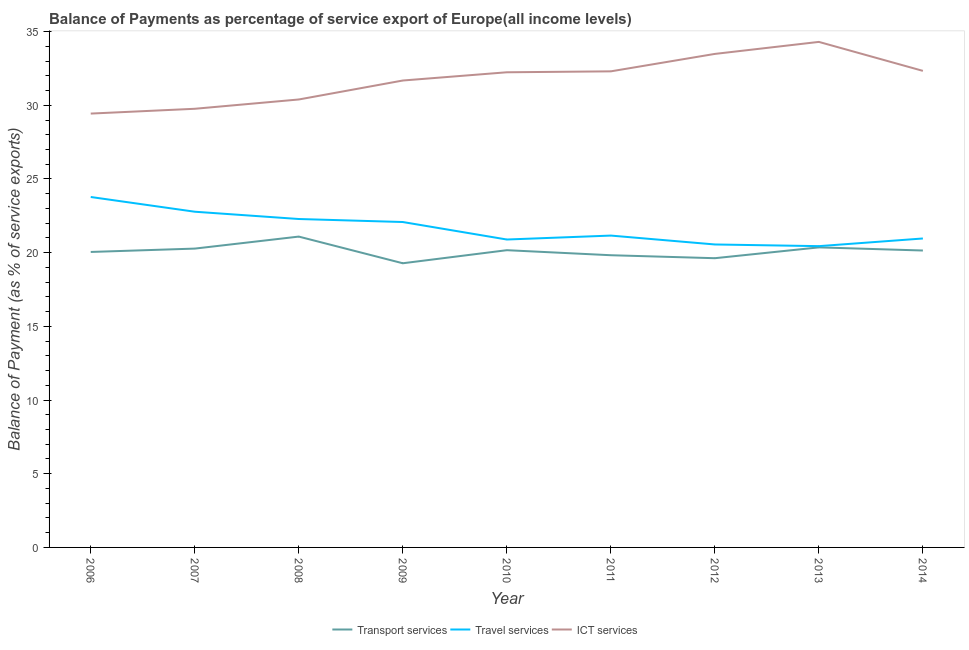How many different coloured lines are there?
Your answer should be compact. 3. What is the balance of payment of ict services in 2014?
Your answer should be very brief. 32.34. Across all years, what is the maximum balance of payment of travel services?
Keep it short and to the point. 23.78. Across all years, what is the minimum balance of payment of travel services?
Your response must be concise. 20.44. In which year was the balance of payment of transport services minimum?
Provide a succinct answer. 2009. What is the total balance of payment of transport services in the graph?
Ensure brevity in your answer.  180.82. What is the difference between the balance of payment of transport services in 2006 and that in 2009?
Provide a short and direct response. 0.77. What is the difference between the balance of payment of travel services in 2007 and the balance of payment of transport services in 2011?
Keep it short and to the point. 2.95. What is the average balance of payment of travel services per year?
Offer a terse response. 21.66. In the year 2007, what is the difference between the balance of payment of travel services and balance of payment of transport services?
Your answer should be very brief. 2.5. What is the ratio of the balance of payment of travel services in 2011 to that in 2012?
Provide a short and direct response. 1.03. Is the balance of payment of ict services in 2010 less than that in 2011?
Make the answer very short. Yes. Is the difference between the balance of payment of transport services in 2009 and 2014 greater than the difference between the balance of payment of ict services in 2009 and 2014?
Keep it short and to the point. No. What is the difference between the highest and the second highest balance of payment of travel services?
Keep it short and to the point. 1. What is the difference between the highest and the lowest balance of payment of transport services?
Offer a terse response. 1.81. Is the sum of the balance of payment of ict services in 2011 and 2012 greater than the maximum balance of payment of transport services across all years?
Ensure brevity in your answer.  Yes. Is it the case that in every year, the sum of the balance of payment of transport services and balance of payment of travel services is greater than the balance of payment of ict services?
Provide a succinct answer. Yes. Is the balance of payment of ict services strictly less than the balance of payment of travel services over the years?
Offer a very short reply. No. What is the difference between two consecutive major ticks on the Y-axis?
Keep it short and to the point. 5. Are the values on the major ticks of Y-axis written in scientific E-notation?
Make the answer very short. No. How many legend labels are there?
Offer a terse response. 3. What is the title of the graph?
Ensure brevity in your answer.  Balance of Payments as percentage of service export of Europe(all income levels). Does "Private sector" appear as one of the legend labels in the graph?
Give a very brief answer. No. What is the label or title of the X-axis?
Offer a terse response. Year. What is the label or title of the Y-axis?
Your answer should be compact. Balance of Payment (as % of service exports). What is the Balance of Payment (as % of service exports) in Transport services in 2006?
Offer a very short reply. 20.05. What is the Balance of Payment (as % of service exports) of Travel services in 2006?
Provide a succinct answer. 23.78. What is the Balance of Payment (as % of service exports) in ICT services in 2006?
Your response must be concise. 29.44. What is the Balance of Payment (as % of service exports) in Transport services in 2007?
Your answer should be compact. 20.28. What is the Balance of Payment (as % of service exports) of Travel services in 2007?
Provide a short and direct response. 22.78. What is the Balance of Payment (as % of service exports) of ICT services in 2007?
Provide a short and direct response. 29.76. What is the Balance of Payment (as % of service exports) of Transport services in 2008?
Ensure brevity in your answer.  21.09. What is the Balance of Payment (as % of service exports) in Travel services in 2008?
Make the answer very short. 22.28. What is the Balance of Payment (as % of service exports) of ICT services in 2008?
Ensure brevity in your answer.  30.39. What is the Balance of Payment (as % of service exports) in Transport services in 2009?
Offer a very short reply. 19.28. What is the Balance of Payment (as % of service exports) in Travel services in 2009?
Give a very brief answer. 22.08. What is the Balance of Payment (as % of service exports) in ICT services in 2009?
Offer a terse response. 31.68. What is the Balance of Payment (as % of service exports) in Transport services in 2010?
Ensure brevity in your answer.  20.17. What is the Balance of Payment (as % of service exports) in Travel services in 2010?
Provide a short and direct response. 20.89. What is the Balance of Payment (as % of service exports) in ICT services in 2010?
Keep it short and to the point. 32.24. What is the Balance of Payment (as % of service exports) of Transport services in 2011?
Offer a very short reply. 19.83. What is the Balance of Payment (as % of service exports) of Travel services in 2011?
Make the answer very short. 21.16. What is the Balance of Payment (as % of service exports) in ICT services in 2011?
Ensure brevity in your answer.  32.3. What is the Balance of Payment (as % of service exports) of Transport services in 2012?
Provide a short and direct response. 19.62. What is the Balance of Payment (as % of service exports) of Travel services in 2012?
Make the answer very short. 20.56. What is the Balance of Payment (as % of service exports) in ICT services in 2012?
Offer a very short reply. 33.49. What is the Balance of Payment (as % of service exports) of Transport services in 2013?
Make the answer very short. 20.36. What is the Balance of Payment (as % of service exports) in Travel services in 2013?
Your answer should be compact. 20.44. What is the Balance of Payment (as % of service exports) in ICT services in 2013?
Give a very brief answer. 34.3. What is the Balance of Payment (as % of service exports) of Transport services in 2014?
Your answer should be compact. 20.15. What is the Balance of Payment (as % of service exports) of Travel services in 2014?
Ensure brevity in your answer.  20.96. What is the Balance of Payment (as % of service exports) in ICT services in 2014?
Give a very brief answer. 32.34. Across all years, what is the maximum Balance of Payment (as % of service exports) of Transport services?
Offer a very short reply. 21.09. Across all years, what is the maximum Balance of Payment (as % of service exports) in Travel services?
Give a very brief answer. 23.78. Across all years, what is the maximum Balance of Payment (as % of service exports) of ICT services?
Make the answer very short. 34.3. Across all years, what is the minimum Balance of Payment (as % of service exports) of Transport services?
Your answer should be compact. 19.28. Across all years, what is the minimum Balance of Payment (as % of service exports) in Travel services?
Your answer should be very brief. 20.44. Across all years, what is the minimum Balance of Payment (as % of service exports) of ICT services?
Ensure brevity in your answer.  29.44. What is the total Balance of Payment (as % of service exports) of Transport services in the graph?
Offer a very short reply. 180.82. What is the total Balance of Payment (as % of service exports) in Travel services in the graph?
Your response must be concise. 194.93. What is the total Balance of Payment (as % of service exports) of ICT services in the graph?
Make the answer very short. 285.94. What is the difference between the Balance of Payment (as % of service exports) of Transport services in 2006 and that in 2007?
Your answer should be compact. -0.23. What is the difference between the Balance of Payment (as % of service exports) in ICT services in 2006 and that in 2007?
Your response must be concise. -0.33. What is the difference between the Balance of Payment (as % of service exports) in Transport services in 2006 and that in 2008?
Your answer should be very brief. -1.04. What is the difference between the Balance of Payment (as % of service exports) of Travel services in 2006 and that in 2008?
Offer a terse response. 1.49. What is the difference between the Balance of Payment (as % of service exports) in ICT services in 2006 and that in 2008?
Ensure brevity in your answer.  -0.96. What is the difference between the Balance of Payment (as % of service exports) of Transport services in 2006 and that in 2009?
Keep it short and to the point. 0.77. What is the difference between the Balance of Payment (as % of service exports) in Travel services in 2006 and that in 2009?
Provide a succinct answer. 1.7. What is the difference between the Balance of Payment (as % of service exports) of ICT services in 2006 and that in 2009?
Give a very brief answer. -2.24. What is the difference between the Balance of Payment (as % of service exports) in Transport services in 2006 and that in 2010?
Offer a very short reply. -0.12. What is the difference between the Balance of Payment (as % of service exports) in Travel services in 2006 and that in 2010?
Keep it short and to the point. 2.88. What is the difference between the Balance of Payment (as % of service exports) in ICT services in 2006 and that in 2010?
Provide a succinct answer. -2.8. What is the difference between the Balance of Payment (as % of service exports) of Transport services in 2006 and that in 2011?
Offer a terse response. 0.22. What is the difference between the Balance of Payment (as % of service exports) in Travel services in 2006 and that in 2011?
Your response must be concise. 2.62. What is the difference between the Balance of Payment (as % of service exports) in ICT services in 2006 and that in 2011?
Your answer should be compact. -2.87. What is the difference between the Balance of Payment (as % of service exports) of Transport services in 2006 and that in 2012?
Your response must be concise. 0.42. What is the difference between the Balance of Payment (as % of service exports) in Travel services in 2006 and that in 2012?
Provide a succinct answer. 3.22. What is the difference between the Balance of Payment (as % of service exports) of ICT services in 2006 and that in 2012?
Provide a succinct answer. -4.05. What is the difference between the Balance of Payment (as % of service exports) in Transport services in 2006 and that in 2013?
Provide a short and direct response. -0.31. What is the difference between the Balance of Payment (as % of service exports) in Travel services in 2006 and that in 2013?
Keep it short and to the point. 3.33. What is the difference between the Balance of Payment (as % of service exports) of ICT services in 2006 and that in 2013?
Ensure brevity in your answer.  -4.86. What is the difference between the Balance of Payment (as % of service exports) of Transport services in 2006 and that in 2014?
Provide a succinct answer. -0.1. What is the difference between the Balance of Payment (as % of service exports) in Travel services in 2006 and that in 2014?
Make the answer very short. 2.81. What is the difference between the Balance of Payment (as % of service exports) in ICT services in 2006 and that in 2014?
Your answer should be very brief. -2.9. What is the difference between the Balance of Payment (as % of service exports) in Transport services in 2007 and that in 2008?
Your answer should be very brief. -0.82. What is the difference between the Balance of Payment (as % of service exports) in Travel services in 2007 and that in 2008?
Your answer should be compact. 0.49. What is the difference between the Balance of Payment (as % of service exports) of ICT services in 2007 and that in 2008?
Offer a very short reply. -0.63. What is the difference between the Balance of Payment (as % of service exports) of Transport services in 2007 and that in 2009?
Offer a very short reply. 0.99. What is the difference between the Balance of Payment (as % of service exports) in Travel services in 2007 and that in 2009?
Your answer should be very brief. 0.7. What is the difference between the Balance of Payment (as % of service exports) in ICT services in 2007 and that in 2009?
Give a very brief answer. -1.92. What is the difference between the Balance of Payment (as % of service exports) in Transport services in 2007 and that in 2010?
Ensure brevity in your answer.  0.11. What is the difference between the Balance of Payment (as % of service exports) in Travel services in 2007 and that in 2010?
Offer a very short reply. 1.89. What is the difference between the Balance of Payment (as % of service exports) in ICT services in 2007 and that in 2010?
Your answer should be compact. -2.48. What is the difference between the Balance of Payment (as % of service exports) in Transport services in 2007 and that in 2011?
Your answer should be very brief. 0.45. What is the difference between the Balance of Payment (as % of service exports) of Travel services in 2007 and that in 2011?
Give a very brief answer. 1.62. What is the difference between the Balance of Payment (as % of service exports) in ICT services in 2007 and that in 2011?
Provide a succinct answer. -2.54. What is the difference between the Balance of Payment (as % of service exports) of Transport services in 2007 and that in 2012?
Give a very brief answer. 0.65. What is the difference between the Balance of Payment (as % of service exports) of Travel services in 2007 and that in 2012?
Give a very brief answer. 2.22. What is the difference between the Balance of Payment (as % of service exports) of ICT services in 2007 and that in 2012?
Your response must be concise. -3.72. What is the difference between the Balance of Payment (as % of service exports) in Transport services in 2007 and that in 2013?
Your answer should be very brief. -0.08. What is the difference between the Balance of Payment (as % of service exports) in Travel services in 2007 and that in 2013?
Your answer should be very brief. 2.34. What is the difference between the Balance of Payment (as % of service exports) of ICT services in 2007 and that in 2013?
Provide a short and direct response. -4.54. What is the difference between the Balance of Payment (as % of service exports) in Transport services in 2007 and that in 2014?
Provide a succinct answer. 0.13. What is the difference between the Balance of Payment (as % of service exports) in Travel services in 2007 and that in 2014?
Your answer should be compact. 1.82. What is the difference between the Balance of Payment (as % of service exports) in ICT services in 2007 and that in 2014?
Ensure brevity in your answer.  -2.57. What is the difference between the Balance of Payment (as % of service exports) of Transport services in 2008 and that in 2009?
Your response must be concise. 1.81. What is the difference between the Balance of Payment (as % of service exports) of Travel services in 2008 and that in 2009?
Provide a succinct answer. 0.2. What is the difference between the Balance of Payment (as % of service exports) of ICT services in 2008 and that in 2009?
Keep it short and to the point. -1.29. What is the difference between the Balance of Payment (as % of service exports) in Travel services in 2008 and that in 2010?
Keep it short and to the point. 1.39. What is the difference between the Balance of Payment (as % of service exports) in ICT services in 2008 and that in 2010?
Ensure brevity in your answer.  -1.85. What is the difference between the Balance of Payment (as % of service exports) in Transport services in 2008 and that in 2011?
Make the answer very short. 1.26. What is the difference between the Balance of Payment (as % of service exports) of Travel services in 2008 and that in 2011?
Keep it short and to the point. 1.12. What is the difference between the Balance of Payment (as % of service exports) in ICT services in 2008 and that in 2011?
Offer a very short reply. -1.91. What is the difference between the Balance of Payment (as % of service exports) in Transport services in 2008 and that in 2012?
Your answer should be very brief. 1.47. What is the difference between the Balance of Payment (as % of service exports) of Travel services in 2008 and that in 2012?
Ensure brevity in your answer.  1.73. What is the difference between the Balance of Payment (as % of service exports) in ICT services in 2008 and that in 2012?
Provide a succinct answer. -3.09. What is the difference between the Balance of Payment (as % of service exports) of Transport services in 2008 and that in 2013?
Make the answer very short. 0.73. What is the difference between the Balance of Payment (as % of service exports) in Travel services in 2008 and that in 2013?
Your answer should be very brief. 1.84. What is the difference between the Balance of Payment (as % of service exports) of ICT services in 2008 and that in 2013?
Your answer should be compact. -3.91. What is the difference between the Balance of Payment (as % of service exports) in Transport services in 2008 and that in 2014?
Your answer should be very brief. 0.94. What is the difference between the Balance of Payment (as % of service exports) in Travel services in 2008 and that in 2014?
Your answer should be compact. 1.32. What is the difference between the Balance of Payment (as % of service exports) in ICT services in 2008 and that in 2014?
Provide a succinct answer. -1.94. What is the difference between the Balance of Payment (as % of service exports) in Transport services in 2009 and that in 2010?
Your answer should be very brief. -0.89. What is the difference between the Balance of Payment (as % of service exports) in Travel services in 2009 and that in 2010?
Give a very brief answer. 1.19. What is the difference between the Balance of Payment (as % of service exports) in ICT services in 2009 and that in 2010?
Provide a succinct answer. -0.56. What is the difference between the Balance of Payment (as % of service exports) of Transport services in 2009 and that in 2011?
Offer a terse response. -0.55. What is the difference between the Balance of Payment (as % of service exports) in Travel services in 2009 and that in 2011?
Ensure brevity in your answer.  0.92. What is the difference between the Balance of Payment (as % of service exports) in ICT services in 2009 and that in 2011?
Your answer should be compact. -0.62. What is the difference between the Balance of Payment (as % of service exports) of Transport services in 2009 and that in 2012?
Provide a short and direct response. -0.34. What is the difference between the Balance of Payment (as % of service exports) of Travel services in 2009 and that in 2012?
Your answer should be very brief. 1.52. What is the difference between the Balance of Payment (as % of service exports) in ICT services in 2009 and that in 2012?
Your answer should be very brief. -1.81. What is the difference between the Balance of Payment (as % of service exports) in Transport services in 2009 and that in 2013?
Your response must be concise. -1.08. What is the difference between the Balance of Payment (as % of service exports) of Travel services in 2009 and that in 2013?
Your response must be concise. 1.64. What is the difference between the Balance of Payment (as % of service exports) of ICT services in 2009 and that in 2013?
Give a very brief answer. -2.62. What is the difference between the Balance of Payment (as % of service exports) in Transport services in 2009 and that in 2014?
Your answer should be very brief. -0.87. What is the difference between the Balance of Payment (as % of service exports) in Travel services in 2009 and that in 2014?
Offer a very short reply. 1.12. What is the difference between the Balance of Payment (as % of service exports) in ICT services in 2009 and that in 2014?
Ensure brevity in your answer.  -0.65. What is the difference between the Balance of Payment (as % of service exports) of Transport services in 2010 and that in 2011?
Your response must be concise. 0.34. What is the difference between the Balance of Payment (as % of service exports) in Travel services in 2010 and that in 2011?
Your response must be concise. -0.27. What is the difference between the Balance of Payment (as % of service exports) of ICT services in 2010 and that in 2011?
Keep it short and to the point. -0.06. What is the difference between the Balance of Payment (as % of service exports) in Transport services in 2010 and that in 2012?
Make the answer very short. 0.54. What is the difference between the Balance of Payment (as % of service exports) in Travel services in 2010 and that in 2012?
Provide a short and direct response. 0.34. What is the difference between the Balance of Payment (as % of service exports) in ICT services in 2010 and that in 2012?
Offer a terse response. -1.25. What is the difference between the Balance of Payment (as % of service exports) of Transport services in 2010 and that in 2013?
Make the answer very short. -0.19. What is the difference between the Balance of Payment (as % of service exports) in Travel services in 2010 and that in 2013?
Offer a terse response. 0.45. What is the difference between the Balance of Payment (as % of service exports) in ICT services in 2010 and that in 2013?
Keep it short and to the point. -2.06. What is the difference between the Balance of Payment (as % of service exports) in Transport services in 2010 and that in 2014?
Keep it short and to the point. 0.02. What is the difference between the Balance of Payment (as % of service exports) in Travel services in 2010 and that in 2014?
Your answer should be very brief. -0.07. What is the difference between the Balance of Payment (as % of service exports) in ICT services in 2010 and that in 2014?
Give a very brief answer. -0.1. What is the difference between the Balance of Payment (as % of service exports) of Transport services in 2011 and that in 2012?
Make the answer very short. 0.2. What is the difference between the Balance of Payment (as % of service exports) in Travel services in 2011 and that in 2012?
Make the answer very short. 0.6. What is the difference between the Balance of Payment (as % of service exports) of ICT services in 2011 and that in 2012?
Your answer should be very brief. -1.18. What is the difference between the Balance of Payment (as % of service exports) of Transport services in 2011 and that in 2013?
Provide a succinct answer. -0.53. What is the difference between the Balance of Payment (as % of service exports) in Travel services in 2011 and that in 2013?
Offer a terse response. 0.72. What is the difference between the Balance of Payment (as % of service exports) of ICT services in 2011 and that in 2013?
Give a very brief answer. -2. What is the difference between the Balance of Payment (as % of service exports) in Transport services in 2011 and that in 2014?
Your response must be concise. -0.32. What is the difference between the Balance of Payment (as % of service exports) of Travel services in 2011 and that in 2014?
Your answer should be very brief. 0.2. What is the difference between the Balance of Payment (as % of service exports) in ICT services in 2011 and that in 2014?
Your response must be concise. -0.03. What is the difference between the Balance of Payment (as % of service exports) in Transport services in 2012 and that in 2013?
Give a very brief answer. -0.73. What is the difference between the Balance of Payment (as % of service exports) in Travel services in 2012 and that in 2013?
Offer a terse response. 0.11. What is the difference between the Balance of Payment (as % of service exports) in ICT services in 2012 and that in 2013?
Give a very brief answer. -0.82. What is the difference between the Balance of Payment (as % of service exports) in Transport services in 2012 and that in 2014?
Your answer should be compact. -0.52. What is the difference between the Balance of Payment (as % of service exports) in Travel services in 2012 and that in 2014?
Your answer should be very brief. -0.41. What is the difference between the Balance of Payment (as % of service exports) in ICT services in 2012 and that in 2014?
Offer a terse response. 1.15. What is the difference between the Balance of Payment (as % of service exports) in Transport services in 2013 and that in 2014?
Your answer should be compact. 0.21. What is the difference between the Balance of Payment (as % of service exports) in Travel services in 2013 and that in 2014?
Provide a succinct answer. -0.52. What is the difference between the Balance of Payment (as % of service exports) of ICT services in 2013 and that in 2014?
Make the answer very short. 1.97. What is the difference between the Balance of Payment (as % of service exports) in Transport services in 2006 and the Balance of Payment (as % of service exports) in Travel services in 2007?
Keep it short and to the point. -2.73. What is the difference between the Balance of Payment (as % of service exports) of Transport services in 2006 and the Balance of Payment (as % of service exports) of ICT services in 2007?
Provide a short and direct response. -9.71. What is the difference between the Balance of Payment (as % of service exports) of Travel services in 2006 and the Balance of Payment (as % of service exports) of ICT services in 2007?
Offer a terse response. -5.99. What is the difference between the Balance of Payment (as % of service exports) of Transport services in 2006 and the Balance of Payment (as % of service exports) of Travel services in 2008?
Keep it short and to the point. -2.23. What is the difference between the Balance of Payment (as % of service exports) of Transport services in 2006 and the Balance of Payment (as % of service exports) of ICT services in 2008?
Your answer should be compact. -10.35. What is the difference between the Balance of Payment (as % of service exports) of Travel services in 2006 and the Balance of Payment (as % of service exports) of ICT services in 2008?
Offer a very short reply. -6.62. What is the difference between the Balance of Payment (as % of service exports) of Transport services in 2006 and the Balance of Payment (as % of service exports) of Travel services in 2009?
Your answer should be compact. -2.03. What is the difference between the Balance of Payment (as % of service exports) in Transport services in 2006 and the Balance of Payment (as % of service exports) in ICT services in 2009?
Ensure brevity in your answer.  -11.63. What is the difference between the Balance of Payment (as % of service exports) of Travel services in 2006 and the Balance of Payment (as % of service exports) of ICT services in 2009?
Provide a succinct answer. -7.9. What is the difference between the Balance of Payment (as % of service exports) in Transport services in 2006 and the Balance of Payment (as % of service exports) in Travel services in 2010?
Your response must be concise. -0.84. What is the difference between the Balance of Payment (as % of service exports) in Transport services in 2006 and the Balance of Payment (as % of service exports) in ICT services in 2010?
Give a very brief answer. -12.19. What is the difference between the Balance of Payment (as % of service exports) in Travel services in 2006 and the Balance of Payment (as % of service exports) in ICT services in 2010?
Provide a short and direct response. -8.46. What is the difference between the Balance of Payment (as % of service exports) in Transport services in 2006 and the Balance of Payment (as % of service exports) in Travel services in 2011?
Your answer should be compact. -1.11. What is the difference between the Balance of Payment (as % of service exports) in Transport services in 2006 and the Balance of Payment (as % of service exports) in ICT services in 2011?
Give a very brief answer. -12.25. What is the difference between the Balance of Payment (as % of service exports) in Travel services in 2006 and the Balance of Payment (as % of service exports) in ICT services in 2011?
Offer a terse response. -8.53. What is the difference between the Balance of Payment (as % of service exports) of Transport services in 2006 and the Balance of Payment (as % of service exports) of Travel services in 2012?
Your response must be concise. -0.51. What is the difference between the Balance of Payment (as % of service exports) of Transport services in 2006 and the Balance of Payment (as % of service exports) of ICT services in 2012?
Give a very brief answer. -13.44. What is the difference between the Balance of Payment (as % of service exports) in Travel services in 2006 and the Balance of Payment (as % of service exports) in ICT services in 2012?
Your answer should be compact. -9.71. What is the difference between the Balance of Payment (as % of service exports) in Transport services in 2006 and the Balance of Payment (as % of service exports) in Travel services in 2013?
Provide a succinct answer. -0.39. What is the difference between the Balance of Payment (as % of service exports) of Transport services in 2006 and the Balance of Payment (as % of service exports) of ICT services in 2013?
Offer a very short reply. -14.25. What is the difference between the Balance of Payment (as % of service exports) of Travel services in 2006 and the Balance of Payment (as % of service exports) of ICT services in 2013?
Offer a very short reply. -10.52. What is the difference between the Balance of Payment (as % of service exports) in Transport services in 2006 and the Balance of Payment (as % of service exports) in Travel services in 2014?
Your answer should be very brief. -0.91. What is the difference between the Balance of Payment (as % of service exports) of Transport services in 2006 and the Balance of Payment (as % of service exports) of ICT services in 2014?
Ensure brevity in your answer.  -12.29. What is the difference between the Balance of Payment (as % of service exports) in Travel services in 2006 and the Balance of Payment (as % of service exports) in ICT services in 2014?
Provide a succinct answer. -8.56. What is the difference between the Balance of Payment (as % of service exports) in Transport services in 2007 and the Balance of Payment (as % of service exports) in Travel services in 2008?
Give a very brief answer. -2.01. What is the difference between the Balance of Payment (as % of service exports) of Transport services in 2007 and the Balance of Payment (as % of service exports) of ICT services in 2008?
Your answer should be compact. -10.12. What is the difference between the Balance of Payment (as % of service exports) in Travel services in 2007 and the Balance of Payment (as % of service exports) in ICT services in 2008?
Offer a very short reply. -7.62. What is the difference between the Balance of Payment (as % of service exports) in Transport services in 2007 and the Balance of Payment (as % of service exports) in Travel services in 2009?
Keep it short and to the point. -1.8. What is the difference between the Balance of Payment (as % of service exports) in Transport services in 2007 and the Balance of Payment (as % of service exports) in ICT services in 2009?
Ensure brevity in your answer.  -11.4. What is the difference between the Balance of Payment (as % of service exports) of Travel services in 2007 and the Balance of Payment (as % of service exports) of ICT services in 2009?
Keep it short and to the point. -8.9. What is the difference between the Balance of Payment (as % of service exports) of Transport services in 2007 and the Balance of Payment (as % of service exports) of Travel services in 2010?
Provide a succinct answer. -0.62. What is the difference between the Balance of Payment (as % of service exports) of Transport services in 2007 and the Balance of Payment (as % of service exports) of ICT services in 2010?
Give a very brief answer. -11.96. What is the difference between the Balance of Payment (as % of service exports) of Travel services in 2007 and the Balance of Payment (as % of service exports) of ICT services in 2010?
Your answer should be compact. -9.46. What is the difference between the Balance of Payment (as % of service exports) of Transport services in 2007 and the Balance of Payment (as % of service exports) of Travel services in 2011?
Offer a very short reply. -0.88. What is the difference between the Balance of Payment (as % of service exports) of Transport services in 2007 and the Balance of Payment (as % of service exports) of ICT services in 2011?
Provide a succinct answer. -12.03. What is the difference between the Balance of Payment (as % of service exports) in Travel services in 2007 and the Balance of Payment (as % of service exports) in ICT services in 2011?
Offer a very short reply. -9.52. What is the difference between the Balance of Payment (as % of service exports) in Transport services in 2007 and the Balance of Payment (as % of service exports) in Travel services in 2012?
Make the answer very short. -0.28. What is the difference between the Balance of Payment (as % of service exports) in Transport services in 2007 and the Balance of Payment (as % of service exports) in ICT services in 2012?
Ensure brevity in your answer.  -13.21. What is the difference between the Balance of Payment (as % of service exports) in Travel services in 2007 and the Balance of Payment (as % of service exports) in ICT services in 2012?
Your answer should be very brief. -10.71. What is the difference between the Balance of Payment (as % of service exports) in Transport services in 2007 and the Balance of Payment (as % of service exports) in Travel services in 2013?
Give a very brief answer. -0.17. What is the difference between the Balance of Payment (as % of service exports) of Transport services in 2007 and the Balance of Payment (as % of service exports) of ICT services in 2013?
Your answer should be very brief. -14.03. What is the difference between the Balance of Payment (as % of service exports) in Travel services in 2007 and the Balance of Payment (as % of service exports) in ICT services in 2013?
Your answer should be very brief. -11.52. What is the difference between the Balance of Payment (as % of service exports) in Transport services in 2007 and the Balance of Payment (as % of service exports) in Travel services in 2014?
Your response must be concise. -0.69. What is the difference between the Balance of Payment (as % of service exports) in Transport services in 2007 and the Balance of Payment (as % of service exports) in ICT services in 2014?
Offer a terse response. -12.06. What is the difference between the Balance of Payment (as % of service exports) of Travel services in 2007 and the Balance of Payment (as % of service exports) of ICT services in 2014?
Ensure brevity in your answer.  -9.56. What is the difference between the Balance of Payment (as % of service exports) of Transport services in 2008 and the Balance of Payment (as % of service exports) of Travel services in 2009?
Your answer should be very brief. -0.99. What is the difference between the Balance of Payment (as % of service exports) of Transport services in 2008 and the Balance of Payment (as % of service exports) of ICT services in 2009?
Offer a very short reply. -10.59. What is the difference between the Balance of Payment (as % of service exports) in Travel services in 2008 and the Balance of Payment (as % of service exports) in ICT services in 2009?
Provide a succinct answer. -9.4. What is the difference between the Balance of Payment (as % of service exports) of Transport services in 2008 and the Balance of Payment (as % of service exports) of Travel services in 2010?
Keep it short and to the point. 0.2. What is the difference between the Balance of Payment (as % of service exports) of Transport services in 2008 and the Balance of Payment (as % of service exports) of ICT services in 2010?
Give a very brief answer. -11.15. What is the difference between the Balance of Payment (as % of service exports) in Travel services in 2008 and the Balance of Payment (as % of service exports) in ICT services in 2010?
Give a very brief answer. -9.96. What is the difference between the Balance of Payment (as % of service exports) in Transport services in 2008 and the Balance of Payment (as % of service exports) in Travel services in 2011?
Provide a short and direct response. -0.07. What is the difference between the Balance of Payment (as % of service exports) in Transport services in 2008 and the Balance of Payment (as % of service exports) in ICT services in 2011?
Give a very brief answer. -11.21. What is the difference between the Balance of Payment (as % of service exports) of Travel services in 2008 and the Balance of Payment (as % of service exports) of ICT services in 2011?
Offer a terse response. -10.02. What is the difference between the Balance of Payment (as % of service exports) in Transport services in 2008 and the Balance of Payment (as % of service exports) in Travel services in 2012?
Make the answer very short. 0.53. What is the difference between the Balance of Payment (as % of service exports) of Transport services in 2008 and the Balance of Payment (as % of service exports) of ICT services in 2012?
Your answer should be compact. -12.39. What is the difference between the Balance of Payment (as % of service exports) in Travel services in 2008 and the Balance of Payment (as % of service exports) in ICT services in 2012?
Ensure brevity in your answer.  -11.2. What is the difference between the Balance of Payment (as % of service exports) of Transport services in 2008 and the Balance of Payment (as % of service exports) of Travel services in 2013?
Offer a terse response. 0.65. What is the difference between the Balance of Payment (as % of service exports) in Transport services in 2008 and the Balance of Payment (as % of service exports) in ICT services in 2013?
Offer a very short reply. -13.21. What is the difference between the Balance of Payment (as % of service exports) of Travel services in 2008 and the Balance of Payment (as % of service exports) of ICT services in 2013?
Provide a succinct answer. -12.02. What is the difference between the Balance of Payment (as % of service exports) in Transport services in 2008 and the Balance of Payment (as % of service exports) in Travel services in 2014?
Your response must be concise. 0.13. What is the difference between the Balance of Payment (as % of service exports) of Transport services in 2008 and the Balance of Payment (as % of service exports) of ICT services in 2014?
Offer a very short reply. -11.24. What is the difference between the Balance of Payment (as % of service exports) in Travel services in 2008 and the Balance of Payment (as % of service exports) in ICT services in 2014?
Offer a very short reply. -10.05. What is the difference between the Balance of Payment (as % of service exports) of Transport services in 2009 and the Balance of Payment (as % of service exports) of Travel services in 2010?
Ensure brevity in your answer.  -1.61. What is the difference between the Balance of Payment (as % of service exports) in Transport services in 2009 and the Balance of Payment (as % of service exports) in ICT services in 2010?
Offer a terse response. -12.96. What is the difference between the Balance of Payment (as % of service exports) in Travel services in 2009 and the Balance of Payment (as % of service exports) in ICT services in 2010?
Offer a very short reply. -10.16. What is the difference between the Balance of Payment (as % of service exports) in Transport services in 2009 and the Balance of Payment (as % of service exports) in Travel services in 2011?
Provide a short and direct response. -1.88. What is the difference between the Balance of Payment (as % of service exports) in Transport services in 2009 and the Balance of Payment (as % of service exports) in ICT services in 2011?
Keep it short and to the point. -13.02. What is the difference between the Balance of Payment (as % of service exports) in Travel services in 2009 and the Balance of Payment (as % of service exports) in ICT services in 2011?
Your answer should be compact. -10.22. What is the difference between the Balance of Payment (as % of service exports) of Transport services in 2009 and the Balance of Payment (as % of service exports) of Travel services in 2012?
Your response must be concise. -1.28. What is the difference between the Balance of Payment (as % of service exports) of Transport services in 2009 and the Balance of Payment (as % of service exports) of ICT services in 2012?
Keep it short and to the point. -14.21. What is the difference between the Balance of Payment (as % of service exports) in Travel services in 2009 and the Balance of Payment (as % of service exports) in ICT services in 2012?
Ensure brevity in your answer.  -11.41. What is the difference between the Balance of Payment (as % of service exports) in Transport services in 2009 and the Balance of Payment (as % of service exports) in Travel services in 2013?
Provide a succinct answer. -1.16. What is the difference between the Balance of Payment (as % of service exports) of Transport services in 2009 and the Balance of Payment (as % of service exports) of ICT services in 2013?
Provide a short and direct response. -15.02. What is the difference between the Balance of Payment (as % of service exports) in Travel services in 2009 and the Balance of Payment (as % of service exports) in ICT services in 2013?
Provide a succinct answer. -12.22. What is the difference between the Balance of Payment (as % of service exports) of Transport services in 2009 and the Balance of Payment (as % of service exports) of Travel services in 2014?
Keep it short and to the point. -1.68. What is the difference between the Balance of Payment (as % of service exports) of Transport services in 2009 and the Balance of Payment (as % of service exports) of ICT services in 2014?
Make the answer very short. -13.05. What is the difference between the Balance of Payment (as % of service exports) of Travel services in 2009 and the Balance of Payment (as % of service exports) of ICT services in 2014?
Your response must be concise. -10.26. What is the difference between the Balance of Payment (as % of service exports) in Transport services in 2010 and the Balance of Payment (as % of service exports) in Travel services in 2011?
Your answer should be compact. -0.99. What is the difference between the Balance of Payment (as % of service exports) of Transport services in 2010 and the Balance of Payment (as % of service exports) of ICT services in 2011?
Ensure brevity in your answer.  -12.13. What is the difference between the Balance of Payment (as % of service exports) in Travel services in 2010 and the Balance of Payment (as % of service exports) in ICT services in 2011?
Provide a succinct answer. -11.41. What is the difference between the Balance of Payment (as % of service exports) of Transport services in 2010 and the Balance of Payment (as % of service exports) of Travel services in 2012?
Your response must be concise. -0.39. What is the difference between the Balance of Payment (as % of service exports) of Transport services in 2010 and the Balance of Payment (as % of service exports) of ICT services in 2012?
Your answer should be compact. -13.32. What is the difference between the Balance of Payment (as % of service exports) of Travel services in 2010 and the Balance of Payment (as % of service exports) of ICT services in 2012?
Ensure brevity in your answer.  -12.59. What is the difference between the Balance of Payment (as % of service exports) of Transport services in 2010 and the Balance of Payment (as % of service exports) of Travel services in 2013?
Offer a terse response. -0.27. What is the difference between the Balance of Payment (as % of service exports) of Transport services in 2010 and the Balance of Payment (as % of service exports) of ICT services in 2013?
Ensure brevity in your answer.  -14.13. What is the difference between the Balance of Payment (as % of service exports) of Travel services in 2010 and the Balance of Payment (as % of service exports) of ICT services in 2013?
Give a very brief answer. -13.41. What is the difference between the Balance of Payment (as % of service exports) of Transport services in 2010 and the Balance of Payment (as % of service exports) of Travel services in 2014?
Your answer should be very brief. -0.79. What is the difference between the Balance of Payment (as % of service exports) of Transport services in 2010 and the Balance of Payment (as % of service exports) of ICT services in 2014?
Your answer should be very brief. -12.17. What is the difference between the Balance of Payment (as % of service exports) in Travel services in 2010 and the Balance of Payment (as % of service exports) in ICT services in 2014?
Provide a succinct answer. -11.44. What is the difference between the Balance of Payment (as % of service exports) in Transport services in 2011 and the Balance of Payment (as % of service exports) in Travel services in 2012?
Give a very brief answer. -0.73. What is the difference between the Balance of Payment (as % of service exports) in Transport services in 2011 and the Balance of Payment (as % of service exports) in ICT services in 2012?
Provide a short and direct response. -13.66. What is the difference between the Balance of Payment (as % of service exports) of Travel services in 2011 and the Balance of Payment (as % of service exports) of ICT services in 2012?
Provide a succinct answer. -12.33. What is the difference between the Balance of Payment (as % of service exports) in Transport services in 2011 and the Balance of Payment (as % of service exports) in Travel services in 2013?
Give a very brief answer. -0.62. What is the difference between the Balance of Payment (as % of service exports) of Transport services in 2011 and the Balance of Payment (as % of service exports) of ICT services in 2013?
Make the answer very short. -14.47. What is the difference between the Balance of Payment (as % of service exports) of Travel services in 2011 and the Balance of Payment (as % of service exports) of ICT services in 2013?
Give a very brief answer. -13.14. What is the difference between the Balance of Payment (as % of service exports) of Transport services in 2011 and the Balance of Payment (as % of service exports) of Travel services in 2014?
Your answer should be compact. -1.14. What is the difference between the Balance of Payment (as % of service exports) in Transport services in 2011 and the Balance of Payment (as % of service exports) in ICT services in 2014?
Make the answer very short. -12.51. What is the difference between the Balance of Payment (as % of service exports) of Travel services in 2011 and the Balance of Payment (as % of service exports) of ICT services in 2014?
Offer a very short reply. -11.18. What is the difference between the Balance of Payment (as % of service exports) of Transport services in 2012 and the Balance of Payment (as % of service exports) of Travel services in 2013?
Give a very brief answer. -0.82. What is the difference between the Balance of Payment (as % of service exports) in Transport services in 2012 and the Balance of Payment (as % of service exports) in ICT services in 2013?
Give a very brief answer. -14.68. What is the difference between the Balance of Payment (as % of service exports) of Travel services in 2012 and the Balance of Payment (as % of service exports) of ICT services in 2013?
Provide a succinct answer. -13.75. What is the difference between the Balance of Payment (as % of service exports) in Transport services in 2012 and the Balance of Payment (as % of service exports) in Travel services in 2014?
Provide a succinct answer. -1.34. What is the difference between the Balance of Payment (as % of service exports) of Transport services in 2012 and the Balance of Payment (as % of service exports) of ICT services in 2014?
Provide a short and direct response. -12.71. What is the difference between the Balance of Payment (as % of service exports) of Travel services in 2012 and the Balance of Payment (as % of service exports) of ICT services in 2014?
Offer a terse response. -11.78. What is the difference between the Balance of Payment (as % of service exports) in Transport services in 2013 and the Balance of Payment (as % of service exports) in Travel services in 2014?
Your answer should be compact. -0.6. What is the difference between the Balance of Payment (as % of service exports) of Transport services in 2013 and the Balance of Payment (as % of service exports) of ICT services in 2014?
Offer a very short reply. -11.98. What is the difference between the Balance of Payment (as % of service exports) in Travel services in 2013 and the Balance of Payment (as % of service exports) in ICT services in 2014?
Your response must be concise. -11.89. What is the average Balance of Payment (as % of service exports) of Transport services per year?
Provide a succinct answer. 20.09. What is the average Balance of Payment (as % of service exports) in Travel services per year?
Your answer should be compact. 21.66. What is the average Balance of Payment (as % of service exports) of ICT services per year?
Give a very brief answer. 31.77. In the year 2006, what is the difference between the Balance of Payment (as % of service exports) in Transport services and Balance of Payment (as % of service exports) in Travel services?
Offer a terse response. -3.73. In the year 2006, what is the difference between the Balance of Payment (as % of service exports) in Transport services and Balance of Payment (as % of service exports) in ICT services?
Ensure brevity in your answer.  -9.39. In the year 2006, what is the difference between the Balance of Payment (as % of service exports) of Travel services and Balance of Payment (as % of service exports) of ICT services?
Your answer should be compact. -5.66. In the year 2007, what is the difference between the Balance of Payment (as % of service exports) of Transport services and Balance of Payment (as % of service exports) of Travel services?
Your answer should be compact. -2.5. In the year 2007, what is the difference between the Balance of Payment (as % of service exports) of Transport services and Balance of Payment (as % of service exports) of ICT services?
Keep it short and to the point. -9.49. In the year 2007, what is the difference between the Balance of Payment (as % of service exports) of Travel services and Balance of Payment (as % of service exports) of ICT services?
Provide a short and direct response. -6.98. In the year 2008, what is the difference between the Balance of Payment (as % of service exports) of Transport services and Balance of Payment (as % of service exports) of Travel services?
Provide a succinct answer. -1.19. In the year 2008, what is the difference between the Balance of Payment (as % of service exports) of Transport services and Balance of Payment (as % of service exports) of ICT services?
Offer a terse response. -9.3. In the year 2008, what is the difference between the Balance of Payment (as % of service exports) in Travel services and Balance of Payment (as % of service exports) in ICT services?
Give a very brief answer. -8.11. In the year 2009, what is the difference between the Balance of Payment (as % of service exports) in Transport services and Balance of Payment (as % of service exports) in Travel services?
Provide a short and direct response. -2.8. In the year 2009, what is the difference between the Balance of Payment (as % of service exports) of Transport services and Balance of Payment (as % of service exports) of ICT services?
Your answer should be very brief. -12.4. In the year 2009, what is the difference between the Balance of Payment (as % of service exports) of Travel services and Balance of Payment (as % of service exports) of ICT services?
Your response must be concise. -9.6. In the year 2010, what is the difference between the Balance of Payment (as % of service exports) in Transport services and Balance of Payment (as % of service exports) in Travel services?
Provide a short and direct response. -0.72. In the year 2010, what is the difference between the Balance of Payment (as % of service exports) of Transport services and Balance of Payment (as % of service exports) of ICT services?
Your answer should be compact. -12.07. In the year 2010, what is the difference between the Balance of Payment (as % of service exports) in Travel services and Balance of Payment (as % of service exports) in ICT services?
Offer a very short reply. -11.35. In the year 2011, what is the difference between the Balance of Payment (as % of service exports) in Transport services and Balance of Payment (as % of service exports) in Travel services?
Keep it short and to the point. -1.33. In the year 2011, what is the difference between the Balance of Payment (as % of service exports) in Transport services and Balance of Payment (as % of service exports) in ICT services?
Keep it short and to the point. -12.48. In the year 2011, what is the difference between the Balance of Payment (as % of service exports) in Travel services and Balance of Payment (as % of service exports) in ICT services?
Your answer should be compact. -11.14. In the year 2012, what is the difference between the Balance of Payment (as % of service exports) in Transport services and Balance of Payment (as % of service exports) in Travel services?
Offer a terse response. -0.93. In the year 2012, what is the difference between the Balance of Payment (as % of service exports) of Transport services and Balance of Payment (as % of service exports) of ICT services?
Offer a very short reply. -13.86. In the year 2012, what is the difference between the Balance of Payment (as % of service exports) in Travel services and Balance of Payment (as % of service exports) in ICT services?
Offer a terse response. -12.93. In the year 2013, what is the difference between the Balance of Payment (as % of service exports) of Transport services and Balance of Payment (as % of service exports) of Travel services?
Provide a short and direct response. -0.08. In the year 2013, what is the difference between the Balance of Payment (as % of service exports) of Transport services and Balance of Payment (as % of service exports) of ICT services?
Offer a terse response. -13.94. In the year 2013, what is the difference between the Balance of Payment (as % of service exports) of Travel services and Balance of Payment (as % of service exports) of ICT services?
Make the answer very short. -13.86. In the year 2014, what is the difference between the Balance of Payment (as % of service exports) in Transport services and Balance of Payment (as % of service exports) in Travel services?
Your answer should be compact. -0.82. In the year 2014, what is the difference between the Balance of Payment (as % of service exports) of Transport services and Balance of Payment (as % of service exports) of ICT services?
Provide a short and direct response. -12.19. In the year 2014, what is the difference between the Balance of Payment (as % of service exports) of Travel services and Balance of Payment (as % of service exports) of ICT services?
Keep it short and to the point. -11.37. What is the ratio of the Balance of Payment (as % of service exports) in Travel services in 2006 to that in 2007?
Your answer should be very brief. 1.04. What is the ratio of the Balance of Payment (as % of service exports) of ICT services in 2006 to that in 2007?
Your answer should be compact. 0.99. What is the ratio of the Balance of Payment (as % of service exports) in Transport services in 2006 to that in 2008?
Your answer should be compact. 0.95. What is the ratio of the Balance of Payment (as % of service exports) in Travel services in 2006 to that in 2008?
Your answer should be compact. 1.07. What is the ratio of the Balance of Payment (as % of service exports) of ICT services in 2006 to that in 2008?
Give a very brief answer. 0.97. What is the ratio of the Balance of Payment (as % of service exports) of Transport services in 2006 to that in 2009?
Keep it short and to the point. 1.04. What is the ratio of the Balance of Payment (as % of service exports) in Travel services in 2006 to that in 2009?
Provide a short and direct response. 1.08. What is the ratio of the Balance of Payment (as % of service exports) of ICT services in 2006 to that in 2009?
Provide a short and direct response. 0.93. What is the ratio of the Balance of Payment (as % of service exports) of Travel services in 2006 to that in 2010?
Your answer should be compact. 1.14. What is the ratio of the Balance of Payment (as % of service exports) of ICT services in 2006 to that in 2010?
Ensure brevity in your answer.  0.91. What is the ratio of the Balance of Payment (as % of service exports) of Transport services in 2006 to that in 2011?
Ensure brevity in your answer.  1.01. What is the ratio of the Balance of Payment (as % of service exports) in Travel services in 2006 to that in 2011?
Your answer should be compact. 1.12. What is the ratio of the Balance of Payment (as % of service exports) of ICT services in 2006 to that in 2011?
Offer a very short reply. 0.91. What is the ratio of the Balance of Payment (as % of service exports) in Transport services in 2006 to that in 2012?
Provide a short and direct response. 1.02. What is the ratio of the Balance of Payment (as % of service exports) of Travel services in 2006 to that in 2012?
Make the answer very short. 1.16. What is the ratio of the Balance of Payment (as % of service exports) of ICT services in 2006 to that in 2012?
Make the answer very short. 0.88. What is the ratio of the Balance of Payment (as % of service exports) of Travel services in 2006 to that in 2013?
Your answer should be very brief. 1.16. What is the ratio of the Balance of Payment (as % of service exports) of ICT services in 2006 to that in 2013?
Keep it short and to the point. 0.86. What is the ratio of the Balance of Payment (as % of service exports) in Travel services in 2006 to that in 2014?
Offer a terse response. 1.13. What is the ratio of the Balance of Payment (as % of service exports) in ICT services in 2006 to that in 2014?
Your response must be concise. 0.91. What is the ratio of the Balance of Payment (as % of service exports) in Transport services in 2007 to that in 2008?
Ensure brevity in your answer.  0.96. What is the ratio of the Balance of Payment (as % of service exports) in Travel services in 2007 to that in 2008?
Keep it short and to the point. 1.02. What is the ratio of the Balance of Payment (as % of service exports) in ICT services in 2007 to that in 2008?
Ensure brevity in your answer.  0.98. What is the ratio of the Balance of Payment (as % of service exports) of Transport services in 2007 to that in 2009?
Keep it short and to the point. 1.05. What is the ratio of the Balance of Payment (as % of service exports) of Travel services in 2007 to that in 2009?
Provide a short and direct response. 1.03. What is the ratio of the Balance of Payment (as % of service exports) of ICT services in 2007 to that in 2009?
Give a very brief answer. 0.94. What is the ratio of the Balance of Payment (as % of service exports) in Transport services in 2007 to that in 2010?
Your response must be concise. 1.01. What is the ratio of the Balance of Payment (as % of service exports) in Travel services in 2007 to that in 2010?
Your answer should be compact. 1.09. What is the ratio of the Balance of Payment (as % of service exports) of ICT services in 2007 to that in 2010?
Provide a short and direct response. 0.92. What is the ratio of the Balance of Payment (as % of service exports) in Transport services in 2007 to that in 2011?
Your response must be concise. 1.02. What is the ratio of the Balance of Payment (as % of service exports) of Travel services in 2007 to that in 2011?
Your answer should be very brief. 1.08. What is the ratio of the Balance of Payment (as % of service exports) of ICT services in 2007 to that in 2011?
Your answer should be very brief. 0.92. What is the ratio of the Balance of Payment (as % of service exports) of Transport services in 2007 to that in 2012?
Your response must be concise. 1.03. What is the ratio of the Balance of Payment (as % of service exports) in Travel services in 2007 to that in 2012?
Keep it short and to the point. 1.11. What is the ratio of the Balance of Payment (as % of service exports) of ICT services in 2007 to that in 2012?
Keep it short and to the point. 0.89. What is the ratio of the Balance of Payment (as % of service exports) of Travel services in 2007 to that in 2013?
Your answer should be compact. 1.11. What is the ratio of the Balance of Payment (as % of service exports) of ICT services in 2007 to that in 2013?
Your answer should be compact. 0.87. What is the ratio of the Balance of Payment (as % of service exports) of Transport services in 2007 to that in 2014?
Provide a succinct answer. 1.01. What is the ratio of the Balance of Payment (as % of service exports) of Travel services in 2007 to that in 2014?
Offer a very short reply. 1.09. What is the ratio of the Balance of Payment (as % of service exports) in ICT services in 2007 to that in 2014?
Your answer should be very brief. 0.92. What is the ratio of the Balance of Payment (as % of service exports) of Transport services in 2008 to that in 2009?
Your answer should be compact. 1.09. What is the ratio of the Balance of Payment (as % of service exports) in Travel services in 2008 to that in 2009?
Offer a very short reply. 1.01. What is the ratio of the Balance of Payment (as % of service exports) in ICT services in 2008 to that in 2009?
Ensure brevity in your answer.  0.96. What is the ratio of the Balance of Payment (as % of service exports) of Transport services in 2008 to that in 2010?
Offer a terse response. 1.05. What is the ratio of the Balance of Payment (as % of service exports) of Travel services in 2008 to that in 2010?
Offer a very short reply. 1.07. What is the ratio of the Balance of Payment (as % of service exports) in ICT services in 2008 to that in 2010?
Provide a short and direct response. 0.94. What is the ratio of the Balance of Payment (as % of service exports) in Transport services in 2008 to that in 2011?
Your response must be concise. 1.06. What is the ratio of the Balance of Payment (as % of service exports) of Travel services in 2008 to that in 2011?
Your response must be concise. 1.05. What is the ratio of the Balance of Payment (as % of service exports) in ICT services in 2008 to that in 2011?
Your answer should be very brief. 0.94. What is the ratio of the Balance of Payment (as % of service exports) in Transport services in 2008 to that in 2012?
Provide a short and direct response. 1.07. What is the ratio of the Balance of Payment (as % of service exports) in Travel services in 2008 to that in 2012?
Give a very brief answer. 1.08. What is the ratio of the Balance of Payment (as % of service exports) of ICT services in 2008 to that in 2012?
Offer a very short reply. 0.91. What is the ratio of the Balance of Payment (as % of service exports) of Transport services in 2008 to that in 2013?
Offer a very short reply. 1.04. What is the ratio of the Balance of Payment (as % of service exports) of Travel services in 2008 to that in 2013?
Your response must be concise. 1.09. What is the ratio of the Balance of Payment (as % of service exports) of ICT services in 2008 to that in 2013?
Keep it short and to the point. 0.89. What is the ratio of the Balance of Payment (as % of service exports) of Transport services in 2008 to that in 2014?
Give a very brief answer. 1.05. What is the ratio of the Balance of Payment (as % of service exports) of Travel services in 2008 to that in 2014?
Offer a terse response. 1.06. What is the ratio of the Balance of Payment (as % of service exports) of Transport services in 2009 to that in 2010?
Give a very brief answer. 0.96. What is the ratio of the Balance of Payment (as % of service exports) of Travel services in 2009 to that in 2010?
Keep it short and to the point. 1.06. What is the ratio of the Balance of Payment (as % of service exports) in ICT services in 2009 to that in 2010?
Offer a very short reply. 0.98. What is the ratio of the Balance of Payment (as % of service exports) of Transport services in 2009 to that in 2011?
Make the answer very short. 0.97. What is the ratio of the Balance of Payment (as % of service exports) of Travel services in 2009 to that in 2011?
Offer a terse response. 1.04. What is the ratio of the Balance of Payment (as % of service exports) of ICT services in 2009 to that in 2011?
Your response must be concise. 0.98. What is the ratio of the Balance of Payment (as % of service exports) of Transport services in 2009 to that in 2012?
Ensure brevity in your answer.  0.98. What is the ratio of the Balance of Payment (as % of service exports) in Travel services in 2009 to that in 2012?
Your answer should be very brief. 1.07. What is the ratio of the Balance of Payment (as % of service exports) of ICT services in 2009 to that in 2012?
Offer a very short reply. 0.95. What is the ratio of the Balance of Payment (as % of service exports) in Transport services in 2009 to that in 2013?
Make the answer very short. 0.95. What is the ratio of the Balance of Payment (as % of service exports) of Travel services in 2009 to that in 2013?
Offer a terse response. 1.08. What is the ratio of the Balance of Payment (as % of service exports) in ICT services in 2009 to that in 2013?
Make the answer very short. 0.92. What is the ratio of the Balance of Payment (as % of service exports) of Travel services in 2009 to that in 2014?
Ensure brevity in your answer.  1.05. What is the ratio of the Balance of Payment (as % of service exports) in ICT services in 2009 to that in 2014?
Give a very brief answer. 0.98. What is the ratio of the Balance of Payment (as % of service exports) of Transport services in 2010 to that in 2011?
Provide a succinct answer. 1.02. What is the ratio of the Balance of Payment (as % of service exports) of Travel services in 2010 to that in 2011?
Make the answer very short. 0.99. What is the ratio of the Balance of Payment (as % of service exports) of ICT services in 2010 to that in 2011?
Ensure brevity in your answer.  1. What is the ratio of the Balance of Payment (as % of service exports) of Transport services in 2010 to that in 2012?
Keep it short and to the point. 1.03. What is the ratio of the Balance of Payment (as % of service exports) of Travel services in 2010 to that in 2012?
Offer a very short reply. 1.02. What is the ratio of the Balance of Payment (as % of service exports) of ICT services in 2010 to that in 2012?
Provide a short and direct response. 0.96. What is the ratio of the Balance of Payment (as % of service exports) of Transport services in 2010 to that in 2013?
Your response must be concise. 0.99. What is the ratio of the Balance of Payment (as % of service exports) of Travel services in 2010 to that in 2013?
Offer a very short reply. 1.02. What is the ratio of the Balance of Payment (as % of service exports) in ICT services in 2010 to that in 2013?
Give a very brief answer. 0.94. What is the ratio of the Balance of Payment (as % of service exports) in ICT services in 2010 to that in 2014?
Your answer should be very brief. 1. What is the ratio of the Balance of Payment (as % of service exports) of Transport services in 2011 to that in 2012?
Your answer should be very brief. 1.01. What is the ratio of the Balance of Payment (as % of service exports) of Travel services in 2011 to that in 2012?
Make the answer very short. 1.03. What is the ratio of the Balance of Payment (as % of service exports) in ICT services in 2011 to that in 2012?
Provide a succinct answer. 0.96. What is the ratio of the Balance of Payment (as % of service exports) in Transport services in 2011 to that in 2013?
Provide a succinct answer. 0.97. What is the ratio of the Balance of Payment (as % of service exports) of Travel services in 2011 to that in 2013?
Your response must be concise. 1.04. What is the ratio of the Balance of Payment (as % of service exports) of ICT services in 2011 to that in 2013?
Your answer should be compact. 0.94. What is the ratio of the Balance of Payment (as % of service exports) in Transport services in 2011 to that in 2014?
Make the answer very short. 0.98. What is the ratio of the Balance of Payment (as % of service exports) of Travel services in 2011 to that in 2014?
Offer a very short reply. 1.01. What is the ratio of the Balance of Payment (as % of service exports) in Transport services in 2012 to that in 2013?
Your answer should be very brief. 0.96. What is the ratio of the Balance of Payment (as % of service exports) of Travel services in 2012 to that in 2013?
Give a very brief answer. 1.01. What is the ratio of the Balance of Payment (as % of service exports) of ICT services in 2012 to that in 2013?
Ensure brevity in your answer.  0.98. What is the ratio of the Balance of Payment (as % of service exports) in Transport services in 2012 to that in 2014?
Give a very brief answer. 0.97. What is the ratio of the Balance of Payment (as % of service exports) in Travel services in 2012 to that in 2014?
Provide a succinct answer. 0.98. What is the ratio of the Balance of Payment (as % of service exports) of ICT services in 2012 to that in 2014?
Offer a terse response. 1.04. What is the ratio of the Balance of Payment (as % of service exports) in Transport services in 2013 to that in 2014?
Offer a terse response. 1.01. What is the ratio of the Balance of Payment (as % of service exports) of Travel services in 2013 to that in 2014?
Offer a very short reply. 0.98. What is the ratio of the Balance of Payment (as % of service exports) in ICT services in 2013 to that in 2014?
Offer a terse response. 1.06. What is the difference between the highest and the second highest Balance of Payment (as % of service exports) in Transport services?
Your response must be concise. 0.73. What is the difference between the highest and the second highest Balance of Payment (as % of service exports) in Travel services?
Offer a terse response. 1. What is the difference between the highest and the second highest Balance of Payment (as % of service exports) in ICT services?
Your response must be concise. 0.82. What is the difference between the highest and the lowest Balance of Payment (as % of service exports) of Transport services?
Make the answer very short. 1.81. What is the difference between the highest and the lowest Balance of Payment (as % of service exports) of Travel services?
Provide a succinct answer. 3.33. What is the difference between the highest and the lowest Balance of Payment (as % of service exports) of ICT services?
Your answer should be very brief. 4.86. 